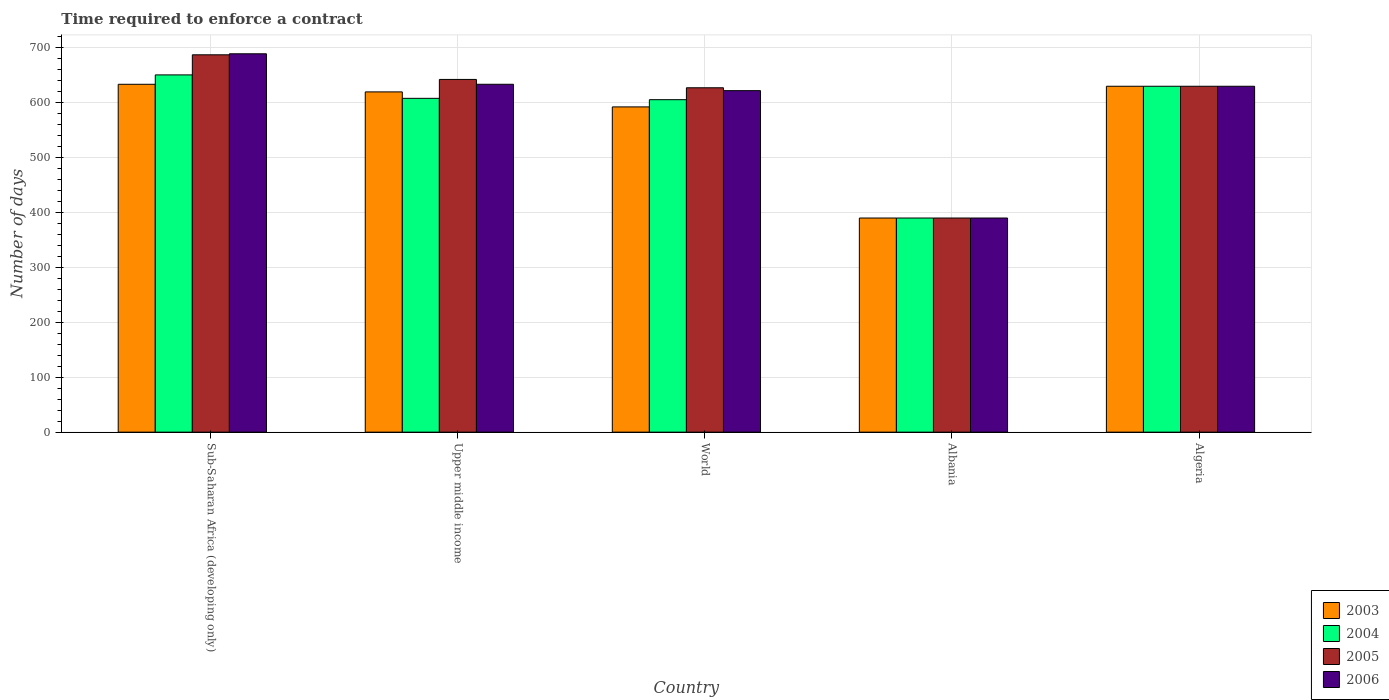How many bars are there on the 2nd tick from the right?
Make the answer very short. 4. What is the label of the 4th group of bars from the left?
Provide a succinct answer. Albania. What is the number of days required to enforce a contract in 2006 in Albania?
Ensure brevity in your answer.  390. Across all countries, what is the maximum number of days required to enforce a contract in 2005?
Your response must be concise. 687.26. Across all countries, what is the minimum number of days required to enforce a contract in 2006?
Your answer should be very brief. 390. In which country was the number of days required to enforce a contract in 2006 maximum?
Provide a succinct answer. Sub-Saharan Africa (developing only). In which country was the number of days required to enforce a contract in 2003 minimum?
Your answer should be compact. Albania. What is the total number of days required to enforce a contract in 2003 in the graph?
Your answer should be compact. 2865.66. What is the difference between the number of days required to enforce a contract in 2006 in Algeria and that in Sub-Saharan Africa (developing only)?
Give a very brief answer. -59.12. What is the difference between the number of days required to enforce a contract in 2006 in World and the number of days required to enforce a contract in 2003 in Albania?
Provide a succinct answer. 231.99. What is the average number of days required to enforce a contract in 2005 per country?
Ensure brevity in your answer.  595.38. What is the difference between the number of days required to enforce a contract of/in 2003 and number of days required to enforce a contract of/in 2006 in Sub-Saharan Africa (developing only)?
Your answer should be very brief. -55.55. In how many countries, is the number of days required to enforce a contract in 2005 greater than 240 days?
Provide a short and direct response. 5. What is the ratio of the number of days required to enforce a contract in 2006 in Albania to that in World?
Your answer should be very brief. 0.63. Is the number of days required to enforce a contract in 2005 in Algeria less than that in Sub-Saharan Africa (developing only)?
Your answer should be compact. Yes. Is the difference between the number of days required to enforce a contract in 2003 in Albania and Algeria greater than the difference between the number of days required to enforce a contract in 2006 in Albania and Algeria?
Make the answer very short. No. What is the difference between the highest and the second highest number of days required to enforce a contract in 2005?
Offer a terse response. 12.41. What is the difference between the highest and the lowest number of days required to enforce a contract in 2003?
Keep it short and to the point. 243.56. In how many countries, is the number of days required to enforce a contract in 2003 greater than the average number of days required to enforce a contract in 2003 taken over all countries?
Offer a terse response. 4. Is the sum of the number of days required to enforce a contract in 2004 in Upper middle income and World greater than the maximum number of days required to enforce a contract in 2006 across all countries?
Keep it short and to the point. Yes. Is it the case that in every country, the sum of the number of days required to enforce a contract in 2006 and number of days required to enforce a contract in 2005 is greater than the sum of number of days required to enforce a contract in 2003 and number of days required to enforce a contract in 2004?
Provide a short and direct response. No. What does the 3rd bar from the right in World represents?
Your response must be concise. 2004. Are all the bars in the graph horizontal?
Your response must be concise. No. What is the difference between two consecutive major ticks on the Y-axis?
Make the answer very short. 100. Does the graph contain any zero values?
Keep it short and to the point. No. Does the graph contain grids?
Give a very brief answer. Yes. Where does the legend appear in the graph?
Provide a succinct answer. Bottom right. How many legend labels are there?
Keep it short and to the point. 4. How are the legend labels stacked?
Make the answer very short. Vertical. What is the title of the graph?
Provide a short and direct response. Time required to enforce a contract. Does "2005" appear as one of the legend labels in the graph?
Keep it short and to the point. Yes. What is the label or title of the X-axis?
Provide a succinct answer. Country. What is the label or title of the Y-axis?
Offer a terse response. Number of days. What is the Number of days of 2003 in Sub-Saharan Africa (developing only)?
Offer a very short reply. 633.56. What is the Number of days of 2004 in Sub-Saharan Africa (developing only)?
Offer a terse response. 650.67. What is the Number of days of 2005 in Sub-Saharan Africa (developing only)?
Ensure brevity in your answer.  687.26. What is the Number of days of 2006 in Sub-Saharan Africa (developing only)?
Offer a very short reply. 689.12. What is the Number of days in 2003 in Upper middle income?
Ensure brevity in your answer.  619.71. What is the Number of days of 2004 in Upper middle income?
Ensure brevity in your answer.  608. What is the Number of days in 2005 in Upper middle income?
Give a very brief answer. 642.41. What is the Number of days of 2006 in Upper middle income?
Your answer should be very brief. 633.6. What is the Number of days in 2003 in World?
Give a very brief answer. 592.38. What is the Number of days of 2004 in World?
Offer a terse response. 605.55. What is the Number of days of 2005 in World?
Ensure brevity in your answer.  627.21. What is the Number of days of 2006 in World?
Your response must be concise. 621.99. What is the Number of days in 2003 in Albania?
Offer a terse response. 390. What is the Number of days in 2004 in Albania?
Make the answer very short. 390. What is the Number of days in 2005 in Albania?
Give a very brief answer. 390. What is the Number of days in 2006 in Albania?
Ensure brevity in your answer.  390. What is the Number of days in 2003 in Algeria?
Provide a short and direct response. 630. What is the Number of days of 2004 in Algeria?
Give a very brief answer. 630. What is the Number of days in 2005 in Algeria?
Your answer should be very brief. 630. What is the Number of days in 2006 in Algeria?
Offer a very short reply. 630. Across all countries, what is the maximum Number of days in 2003?
Your answer should be compact. 633.56. Across all countries, what is the maximum Number of days in 2004?
Your answer should be compact. 650.67. Across all countries, what is the maximum Number of days of 2005?
Make the answer very short. 687.26. Across all countries, what is the maximum Number of days in 2006?
Keep it short and to the point. 689.12. Across all countries, what is the minimum Number of days in 2003?
Make the answer very short. 390. Across all countries, what is the minimum Number of days in 2004?
Offer a terse response. 390. Across all countries, what is the minimum Number of days of 2005?
Make the answer very short. 390. Across all countries, what is the minimum Number of days in 2006?
Ensure brevity in your answer.  390. What is the total Number of days of 2003 in the graph?
Offer a terse response. 2865.66. What is the total Number of days in 2004 in the graph?
Provide a short and direct response. 2884.22. What is the total Number of days in 2005 in the graph?
Keep it short and to the point. 2976.89. What is the total Number of days of 2006 in the graph?
Ensure brevity in your answer.  2964.71. What is the difference between the Number of days in 2003 in Sub-Saharan Africa (developing only) and that in Upper middle income?
Make the answer very short. 13.85. What is the difference between the Number of days in 2004 in Sub-Saharan Africa (developing only) and that in Upper middle income?
Keep it short and to the point. 42.67. What is the difference between the Number of days in 2005 in Sub-Saharan Africa (developing only) and that in Upper middle income?
Give a very brief answer. 44.85. What is the difference between the Number of days in 2006 in Sub-Saharan Africa (developing only) and that in Upper middle income?
Ensure brevity in your answer.  55.52. What is the difference between the Number of days in 2003 in Sub-Saharan Africa (developing only) and that in World?
Your response must be concise. 41.18. What is the difference between the Number of days in 2004 in Sub-Saharan Africa (developing only) and that in World?
Your response must be concise. 45.12. What is the difference between the Number of days in 2005 in Sub-Saharan Africa (developing only) and that in World?
Your answer should be compact. 60.05. What is the difference between the Number of days of 2006 in Sub-Saharan Africa (developing only) and that in World?
Ensure brevity in your answer.  67.12. What is the difference between the Number of days in 2003 in Sub-Saharan Africa (developing only) and that in Albania?
Offer a very short reply. 243.56. What is the difference between the Number of days of 2004 in Sub-Saharan Africa (developing only) and that in Albania?
Your response must be concise. 260.67. What is the difference between the Number of days in 2005 in Sub-Saharan Africa (developing only) and that in Albania?
Give a very brief answer. 297.26. What is the difference between the Number of days in 2006 in Sub-Saharan Africa (developing only) and that in Albania?
Keep it short and to the point. 299.12. What is the difference between the Number of days of 2003 in Sub-Saharan Africa (developing only) and that in Algeria?
Provide a succinct answer. 3.56. What is the difference between the Number of days of 2004 in Sub-Saharan Africa (developing only) and that in Algeria?
Keep it short and to the point. 20.67. What is the difference between the Number of days of 2005 in Sub-Saharan Africa (developing only) and that in Algeria?
Offer a very short reply. 57.26. What is the difference between the Number of days of 2006 in Sub-Saharan Africa (developing only) and that in Algeria?
Keep it short and to the point. 59.12. What is the difference between the Number of days in 2003 in Upper middle income and that in World?
Offer a very short reply. 27.33. What is the difference between the Number of days of 2004 in Upper middle income and that in World?
Make the answer very short. 2.45. What is the difference between the Number of days in 2005 in Upper middle income and that in World?
Give a very brief answer. 15.19. What is the difference between the Number of days of 2006 in Upper middle income and that in World?
Offer a very short reply. 11.61. What is the difference between the Number of days of 2003 in Upper middle income and that in Albania?
Offer a terse response. 229.71. What is the difference between the Number of days in 2004 in Upper middle income and that in Albania?
Your answer should be compact. 218. What is the difference between the Number of days in 2005 in Upper middle income and that in Albania?
Provide a short and direct response. 252.41. What is the difference between the Number of days of 2006 in Upper middle income and that in Albania?
Your answer should be compact. 243.6. What is the difference between the Number of days of 2003 in Upper middle income and that in Algeria?
Make the answer very short. -10.29. What is the difference between the Number of days of 2005 in Upper middle income and that in Algeria?
Provide a short and direct response. 12.41. What is the difference between the Number of days in 2006 in Upper middle income and that in Algeria?
Offer a terse response. 3.6. What is the difference between the Number of days of 2003 in World and that in Albania?
Offer a terse response. 202.38. What is the difference between the Number of days in 2004 in World and that in Albania?
Offer a very short reply. 215.55. What is the difference between the Number of days of 2005 in World and that in Albania?
Offer a terse response. 237.21. What is the difference between the Number of days of 2006 in World and that in Albania?
Your answer should be very brief. 231.99. What is the difference between the Number of days of 2003 in World and that in Algeria?
Ensure brevity in your answer.  -37.62. What is the difference between the Number of days in 2004 in World and that in Algeria?
Ensure brevity in your answer.  -24.45. What is the difference between the Number of days in 2005 in World and that in Algeria?
Provide a succinct answer. -2.79. What is the difference between the Number of days in 2006 in World and that in Algeria?
Your answer should be very brief. -8.01. What is the difference between the Number of days of 2003 in Albania and that in Algeria?
Provide a succinct answer. -240. What is the difference between the Number of days of 2004 in Albania and that in Algeria?
Keep it short and to the point. -240. What is the difference between the Number of days of 2005 in Albania and that in Algeria?
Provide a short and direct response. -240. What is the difference between the Number of days in 2006 in Albania and that in Algeria?
Your answer should be compact. -240. What is the difference between the Number of days of 2003 in Sub-Saharan Africa (developing only) and the Number of days of 2004 in Upper middle income?
Your answer should be very brief. 25.56. What is the difference between the Number of days of 2003 in Sub-Saharan Africa (developing only) and the Number of days of 2005 in Upper middle income?
Provide a short and direct response. -8.85. What is the difference between the Number of days of 2003 in Sub-Saharan Africa (developing only) and the Number of days of 2006 in Upper middle income?
Provide a short and direct response. -0.04. What is the difference between the Number of days in 2004 in Sub-Saharan Africa (developing only) and the Number of days in 2005 in Upper middle income?
Keep it short and to the point. 8.26. What is the difference between the Number of days of 2004 in Sub-Saharan Africa (developing only) and the Number of days of 2006 in Upper middle income?
Keep it short and to the point. 17.07. What is the difference between the Number of days in 2005 in Sub-Saharan Africa (developing only) and the Number of days in 2006 in Upper middle income?
Provide a short and direct response. 53.66. What is the difference between the Number of days in 2003 in Sub-Saharan Africa (developing only) and the Number of days in 2004 in World?
Your answer should be compact. 28.01. What is the difference between the Number of days of 2003 in Sub-Saharan Africa (developing only) and the Number of days of 2005 in World?
Keep it short and to the point. 6.35. What is the difference between the Number of days of 2003 in Sub-Saharan Africa (developing only) and the Number of days of 2006 in World?
Give a very brief answer. 11.57. What is the difference between the Number of days in 2004 in Sub-Saharan Africa (developing only) and the Number of days in 2005 in World?
Your answer should be compact. 23.45. What is the difference between the Number of days in 2004 in Sub-Saharan Africa (developing only) and the Number of days in 2006 in World?
Ensure brevity in your answer.  28.67. What is the difference between the Number of days in 2005 in Sub-Saharan Africa (developing only) and the Number of days in 2006 in World?
Keep it short and to the point. 65.27. What is the difference between the Number of days of 2003 in Sub-Saharan Africa (developing only) and the Number of days of 2004 in Albania?
Provide a short and direct response. 243.56. What is the difference between the Number of days in 2003 in Sub-Saharan Africa (developing only) and the Number of days in 2005 in Albania?
Provide a succinct answer. 243.56. What is the difference between the Number of days in 2003 in Sub-Saharan Africa (developing only) and the Number of days in 2006 in Albania?
Keep it short and to the point. 243.56. What is the difference between the Number of days of 2004 in Sub-Saharan Africa (developing only) and the Number of days of 2005 in Albania?
Offer a very short reply. 260.67. What is the difference between the Number of days of 2004 in Sub-Saharan Africa (developing only) and the Number of days of 2006 in Albania?
Ensure brevity in your answer.  260.67. What is the difference between the Number of days of 2005 in Sub-Saharan Africa (developing only) and the Number of days of 2006 in Albania?
Give a very brief answer. 297.26. What is the difference between the Number of days in 2003 in Sub-Saharan Africa (developing only) and the Number of days in 2004 in Algeria?
Your answer should be very brief. 3.56. What is the difference between the Number of days in 2003 in Sub-Saharan Africa (developing only) and the Number of days in 2005 in Algeria?
Offer a terse response. 3.56. What is the difference between the Number of days in 2003 in Sub-Saharan Africa (developing only) and the Number of days in 2006 in Algeria?
Your response must be concise. 3.56. What is the difference between the Number of days of 2004 in Sub-Saharan Africa (developing only) and the Number of days of 2005 in Algeria?
Provide a succinct answer. 20.67. What is the difference between the Number of days in 2004 in Sub-Saharan Africa (developing only) and the Number of days in 2006 in Algeria?
Ensure brevity in your answer.  20.67. What is the difference between the Number of days of 2005 in Sub-Saharan Africa (developing only) and the Number of days of 2006 in Algeria?
Provide a short and direct response. 57.26. What is the difference between the Number of days in 2003 in Upper middle income and the Number of days in 2004 in World?
Give a very brief answer. 14.17. What is the difference between the Number of days of 2003 in Upper middle income and the Number of days of 2005 in World?
Provide a short and direct response. -7.5. What is the difference between the Number of days of 2003 in Upper middle income and the Number of days of 2006 in World?
Make the answer very short. -2.28. What is the difference between the Number of days of 2004 in Upper middle income and the Number of days of 2005 in World?
Give a very brief answer. -19.21. What is the difference between the Number of days of 2004 in Upper middle income and the Number of days of 2006 in World?
Make the answer very short. -13.99. What is the difference between the Number of days in 2005 in Upper middle income and the Number of days in 2006 in World?
Provide a succinct answer. 20.42. What is the difference between the Number of days in 2003 in Upper middle income and the Number of days in 2004 in Albania?
Make the answer very short. 229.71. What is the difference between the Number of days in 2003 in Upper middle income and the Number of days in 2005 in Albania?
Provide a succinct answer. 229.71. What is the difference between the Number of days in 2003 in Upper middle income and the Number of days in 2006 in Albania?
Provide a short and direct response. 229.71. What is the difference between the Number of days of 2004 in Upper middle income and the Number of days of 2005 in Albania?
Keep it short and to the point. 218. What is the difference between the Number of days in 2004 in Upper middle income and the Number of days in 2006 in Albania?
Give a very brief answer. 218. What is the difference between the Number of days in 2005 in Upper middle income and the Number of days in 2006 in Albania?
Provide a short and direct response. 252.41. What is the difference between the Number of days in 2003 in Upper middle income and the Number of days in 2004 in Algeria?
Make the answer very short. -10.29. What is the difference between the Number of days of 2003 in Upper middle income and the Number of days of 2005 in Algeria?
Provide a short and direct response. -10.29. What is the difference between the Number of days of 2003 in Upper middle income and the Number of days of 2006 in Algeria?
Offer a very short reply. -10.29. What is the difference between the Number of days in 2004 in Upper middle income and the Number of days in 2005 in Algeria?
Provide a succinct answer. -22. What is the difference between the Number of days in 2004 in Upper middle income and the Number of days in 2006 in Algeria?
Your response must be concise. -22. What is the difference between the Number of days in 2005 in Upper middle income and the Number of days in 2006 in Algeria?
Provide a succinct answer. 12.41. What is the difference between the Number of days in 2003 in World and the Number of days in 2004 in Albania?
Offer a very short reply. 202.38. What is the difference between the Number of days in 2003 in World and the Number of days in 2005 in Albania?
Ensure brevity in your answer.  202.38. What is the difference between the Number of days of 2003 in World and the Number of days of 2006 in Albania?
Your answer should be very brief. 202.38. What is the difference between the Number of days in 2004 in World and the Number of days in 2005 in Albania?
Offer a terse response. 215.55. What is the difference between the Number of days of 2004 in World and the Number of days of 2006 in Albania?
Keep it short and to the point. 215.55. What is the difference between the Number of days of 2005 in World and the Number of days of 2006 in Albania?
Your answer should be very brief. 237.21. What is the difference between the Number of days in 2003 in World and the Number of days in 2004 in Algeria?
Provide a short and direct response. -37.62. What is the difference between the Number of days of 2003 in World and the Number of days of 2005 in Algeria?
Offer a very short reply. -37.62. What is the difference between the Number of days in 2003 in World and the Number of days in 2006 in Algeria?
Ensure brevity in your answer.  -37.62. What is the difference between the Number of days of 2004 in World and the Number of days of 2005 in Algeria?
Your answer should be very brief. -24.45. What is the difference between the Number of days of 2004 in World and the Number of days of 2006 in Algeria?
Your response must be concise. -24.45. What is the difference between the Number of days of 2005 in World and the Number of days of 2006 in Algeria?
Offer a terse response. -2.79. What is the difference between the Number of days in 2003 in Albania and the Number of days in 2004 in Algeria?
Make the answer very short. -240. What is the difference between the Number of days in 2003 in Albania and the Number of days in 2005 in Algeria?
Provide a short and direct response. -240. What is the difference between the Number of days of 2003 in Albania and the Number of days of 2006 in Algeria?
Your answer should be very brief. -240. What is the difference between the Number of days in 2004 in Albania and the Number of days in 2005 in Algeria?
Make the answer very short. -240. What is the difference between the Number of days of 2004 in Albania and the Number of days of 2006 in Algeria?
Your answer should be very brief. -240. What is the difference between the Number of days of 2005 in Albania and the Number of days of 2006 in Algeria?
Your answer should be very brief. -240. What is the average Number of days of 2003 per country?
Provide a succinct answer. 573.13. What is the average Number of days of 2004 per country?
Provide a succinct answer. 576.84. What is the average Number of days of 2005 per country?
Make the answer very short. 595.38. What is the average Number of days in 2006 per country?
Your answer should be compact. 592.94. What is the difference between the Number of days of 2003 and Number of days of 2004 in Sub-Saharan Africa (developing only)?
Provide a short and direct response. -17.1. What is the difference between the Number of days in 2003 and Number of days in 2005 in Sub-Saharan Africa (developing only)?
Offer a very short reply. -53.7. What is the difference between the Number of days in 2003 and Number of days in 2006 in Sub-Saharan Africa (developing only)?
Offer a very short reply. -55.55. What is the difference between the Number of days in 2004 and Number of days in 2005 in Sub-Saharan Africa (developing only)?
Offer a terse response. -36.6. What is the difference between the Number of days of 2004 and Number of days of 2006 in Sub-Saharan Africa (developing only)?
Provide a short and direct response. -38.45. What is the difference between the Number of days of 2005 and Number of days of 2006 in Sub-Saharan Africa (developing only)?
Make the answer very short. -1.85. What is the difference between the Number of days of 2003 and Number of days of 2004 in Upper middle income?
Keep it short and to the point. 11.71. What is the difference between the Number of days in 2003 and Number of days in 2005 in Upper middle income?
Your response must be concise. -22.69. What is the difference between the Number of days in 2003 and Number of days in 2006 in Upper middle income?
Your answer should be very brief. -13.89. What is the difference between the Number of days in 2004 and Number of days in 2005 in Upper middle income?
Ensure brevity in your answer.  -34.41. What is the difference between the Number of days of 2004 and Number of days of 2006 in Upper middle income?
Your answer should be compact. -25.6. What is the difference between the Number of days in 2005 and Number of days in 2006 in Upper middle income?
Offer a very short reply. 8.81. What is the difference between the Number of days of 2003 and Number of days of 2004 in World?
Your response must be concise. -13.17. What is the difference between the Number of days in 2003 and Number of days in 2005 in World?
Offer a terse response. -34.83. What is the difference between the Number of days of 2003 and Number of days of 2006 in World?
Keep it short and to the point. -29.61. What is the difference between the Number of days in 2004 and Number of days in 2005 in World?
Keep it short and to the point. -21.67. What is the difference between the Number of days in 2004 and Number of days in 2006 in World?
Ensure brevity in your answer.  -16.45. What is the difference between the Number of days of 2005 and Number of days of 2006 in World?
Offer a terse response. 5.22. What is the difference between the Number of days of 2003 and Number of days of 2004 in Albania?
Provide a succinct answer. 0. What is the difference between the Number of days of 2003 and Number of days of 2005 in Albania?
Offer a very short reply. 0. What is the difference between the Number of days of 2003 and Number of days of 2006 in Albania?
Your response must be concise. 0. What is the difference between the Number of days of 2004 and Number of days of 2006 in Albania?
Provide a succinct answer. 0. What is the difference between the Number of days of 2005 and Number of days of 2006 in Albania?
Keep it short and to the point. 0. What is the difference between the Number of days of 2003 and Number of days of 2005 in Algeria?
Keep it short and to the point. 0. What is the ratio of the Number of days in 2003 in Sub-Saharan Africa (developing only) to that in Upper middle income?
Your answer should be compact. 1.02. What is the ratio of the Number of days in 2004 in Sub-Saharan Africa (developing only) to that in Upper middle income?
Make the answer very short. 1.07. What is the ratio of the Number of days in 2005 in Sub-Saharan Africa (developing only) to that in Upper middle income?
Offer a very short reply. 1.07. What is the ratio of the Number of days of 2006 in Sub-Saharan Africa (developing only) to that in Upper middle income?
Make the answer very short. 1.09. What is the ratio of the Number of days of 2003 in Sub-Saharan Africa (developing only) to that in World?
Give a very brief answer. 1.07. What is the ratio of the Number of days in 2004 in Sub-Saharan Africa (developing only) to that in World?
Provide a short and direct response. 1.07. What is the ratio of the Number of days in 2005 in Sub-Saharan Africa (developing only) to that in World?
Keep it short and to the point. 1.1. What is the ratio of the Number of days in 2006 in Sub-Saharan Africa (developing only) to that in World?
Ensure brevity in your answer.  1.11. What is the ratio of the Number of days of 2003 in Sub-Saharan Africa (developing only) to that in Albania?
Your response must be concise. 1.62. What is the ratio of the Number of days of 2004 in Sub-Saharan Africa (developing only) to that in Albania?
Make the answer very short. 1.67. What is the ratio of the Number of days of 2005 in Sub-Saharan Africa (developing only) to that in Albania?
Make the answer very short. 1.76. What is the ratio of the Number of days of 2006 in Sub-Saharan Africa (developing only) to that in Albania?
Keep it short and to the point. 1.77. What is the ratio of the Number of days of 2004 in Sub-Saharan Africa (developing only) to that in Algeria?
Offer a very short reply. 1.03. What is the ratio of the Number of days of 2005 in Sub-Saharan Africa (developing only) to that in Algeria?
Ensure brevity in your answer.  1.09. What is the ratio of the Number of days in 2006 in Sub-Saharan Africa (developing only) to that in Algeria?
Keep it short and to the point. 1.09. What is the ratio of the Number of days in 2003 in Upper middle income to that in World?
Offer a terse response. 1.05. What is the ratio of the Number of days of 2004 in Upper middle income to that in World?
Offer a very short reply. 1. What is the ratio of the Number of days in 2005 in Upper middle income to that in World?
Ensure brevity in your answer.  1.02. What is the ratio of the Number of days in 2006 in Upper middle income to that in World?
Your response must be concise. 1.02. What is the ratio of the Number of days in 2003 in Upper middle income to that in Albania?
Offer a very short reply. 1.59. What is the ratio of the Number of days of 2004 in Upper middle income to that in Albania?
Your response must be concise. 1.56. What is the ratio of the Number of days in 2005 in Upper middle income to that in Albania?
Your answer should be very brief. 1.65. What is the ratio of the Number of days in 2006 in Upper middle income to that in Albania?
Your response must be concise. 1.62. What is the ratio of the Number of days of 2003 in Upper middle income to that in Algeria?
Offer a terse response. 0.98. What is the ratio of the Number of days of 2004 in Upper middle income to that in Algeria?
Provide a succinct answer. 0.97. What is the ratio of the Number of days in 2005 in Upper middle income to that in Algeria?
Offer a very short reply. 1.02. What is the ratio of the Number of days of 2006 in Upper middle income to that in Algeria?
Keep it short and to the point. 1.01. What is the ratio of the Number of days of 2003 in World to that in Albania?
Offer a terse response. 1.52. What is the ratio of the Number of days of 2004 in World to that in Albania?
Provide a short and direct response. 1.55. What is the ratio of the Number of days of 2005 in World to that in Albania?
Provide a short and direct response. 1.61. What is the ratio of the Number of days of 2006 in World to that in Albania?
Your answer should be compact. 1.59. What is the ratio of the Number of days in 2003 in World to that in Algeria?
Your answer should be compact. 0.94. What is the ratio of the Number of days of 2004 in World to that in Algeria?
Your answer should be very brief. 0.96. What is the ratio of the Number of days in 2006 in World to that in Algeria?
Provide a short and direct response. 0.99. What is the ratio of the Number of days in 2003 in Albania to that in Algeria?
Provide a short and direct response. 0.62. What is the ratio of the Number of days in 2004 in Albania to that in Algeria?
Keep it short and to the point. 0.62. What is the ratio of the Number of days of 2005 in Albania to that in Algeria?
Offer a very short reply. 0.62. What is the ratio of the Number of days of 2006 in Albania to that in Algeria?
Give a very brief answer. 0.62. What is the difference between the highest and the second highest Number of days in 2003?
Offer a terse response. 3.56. What is the difference between the highest and the second highest Number of days of 2004?
Make the answer very short. 20.67. What is the difference between the highest and the second highest Number of days of 2005?
Offer a terse response. 44.85. What is the difference between the highest and the second highest Number of days in 2006?
Your response must be concise. 55.52. What is the difference between the highest and the lowest Number of days of 2003?
Make the answer very short. 243.56. What is the difference between the highest and the lowest Number of days in 2004?
Offer a terse response. 260.67. What is the difference between the highest and the lowest Number of days in 2005?
Offer a very short reply. 297.26. What is the difference between the highest and the lowest Number of days in 2006?
Give a very brief answer. 299.12. 